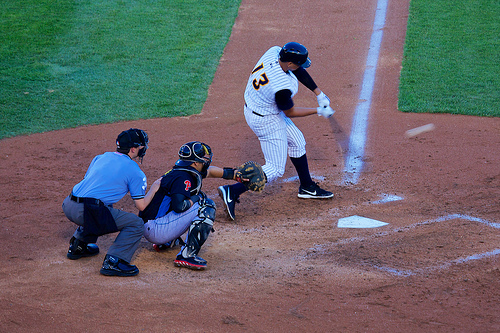Is the player wearing a glove? Yes, the catcher is wearing a glove, essential for catching the high-speed balls during the game. 